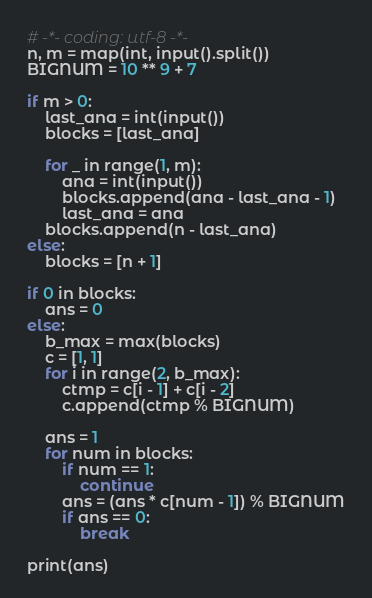<code> <loc_0><loc_0><loc_500><loc_500><_Python_># -*- coding: utf-8 -*-
n, m = map(int, input().split())
BIGNUM = 10 ** 9 + 7

if m > 0:
    last_ana = int(input())
    blocks = [last_ana]

    for _ in range(1, m):
        ana = int(input())
        blocks.append(ana - last_ana - 1)
        last_ana = ana
    blocks.append(n - last_ana)
else:
    blocks = [n + 1]

if 0 in blocks:
    ans = 0
else:
    b_max = max(blocks)
    c = [1, 1]
    for i in range(2, b_max):
        ctmp = c[i - 1] + c[i - 2]
        c.append(ctmp % BIGNUM)

    ans = 1
    for num in blocks:
        if num == 1:
            continue
        ans = (ans * c[num - 1]) % BIGNUM
        if ans == 0:
            break

print(ans)</code> 